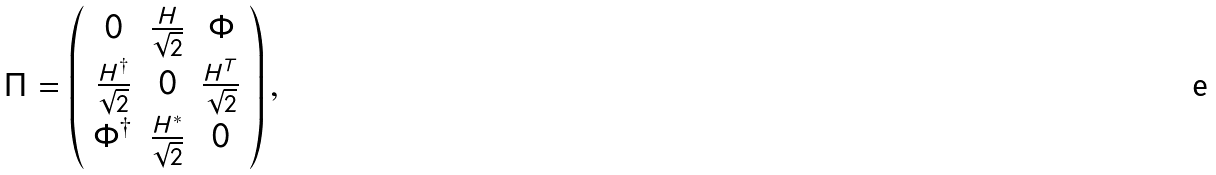Convert formula to latex. <formula><loc_0><loc_0><loc_500><loc_500>\Pi = \left ( \begin{array} { c c c } 0 & \frac { H } { \sqrt { 2 } } & \Phi \\ \frac { H ^ { \dagger } } { \sqrt { 2 } } & 0 & \frac { H ^ { T } } { \sqrt { 2 } } \\ \Phi ^ { \dagger } & \frac { H ^ { * } } { \sqrt { 2 } } & 0 \end{array} \right ) ,</formula> 